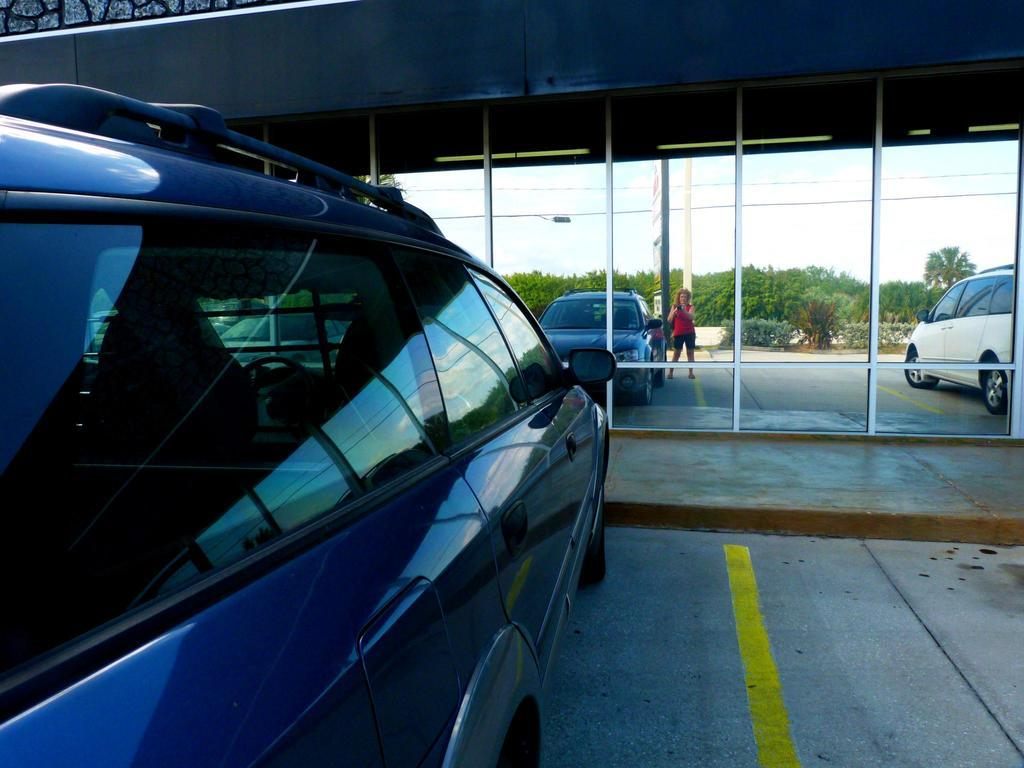What object in the image allows for reflection? There is a mirror in the image. What type of vehicles can be seen in the image? There are cars in the image. What type of natural elements are present in the image? There are trees in the image. Can you describe the person in the image? There is a person standing in the image. How many sisters are present in the image? There is no mention of sisters in the image; only a person is mentioned. What type of key is being used to unlock the car in the image? There is no key or car being unlocked in the image; only cars are mentioned. 